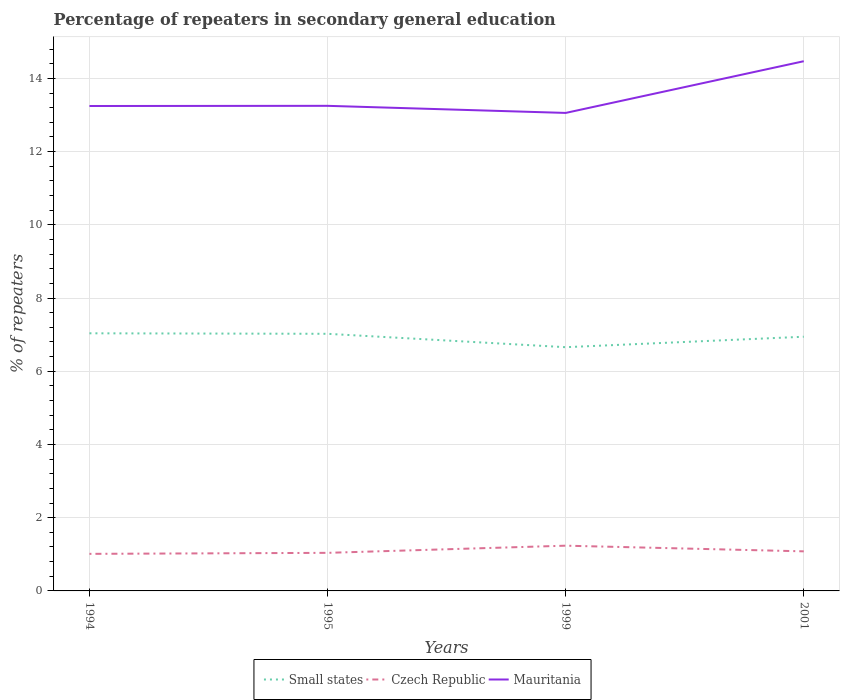Does the line corresponding to Mauritania intersect with the line corresponding to Czech Republic?
Your answer should be compact. No. Is the number of lines equal to the number of legend labels?
Provide a short and direct response. Yes. Across all years, what is the maximum percentage of repeaters in secondary general education in Czech Republic?
Provide a succinct answer. 1.01. What is the total percentage of repeaters in secondary general education in Czech Republic in the graph?
Give a very brief answer. -0.07. What is the difference between the highest and the second highest percentage of repeaters in secondary general education in Czech Republic?
Ensure brevity in your answer.  0.22. Is the percentage of repeaters in secondary general education in Mauritania strictly greater than the percentage of repeaters in secondary general education in Czech Republic over the years?
Make the answer very short. No. How many lines are there?
Offer a terse response. 3. What is the difference between two consecutive major ticks on the Y-axis?
Ensure brevity in your answer.  2. Are the values on the major ticks of Y-axis written in scientific E-notation?
Provide a succinct answer. No. Where does the legend appear in the graph?
Provide a short and direct response. Bottom center. How many legend labels are there?
Your response must be concise. 3. What is the title of the graph?
Your response must be concise. Percentage of repeaters in secondary general education. What is the label or title of the X-axis?
Provide a succinct answer. Years. What is the label or title of the Y-axis?
Offer a very short reply. % of repeaters. What is the % of repeaters of Small states in 1994?
Your answer should be compact. 7.04. What is the % of repeaters in Czech Republic in 1994?
Provide a short and direct response. 1.01. What is the % of repeaters in Mauritania in 1994?
Offer a terse response. 13.25. What is the % of repeaters of Small states in 1995?
Provide a succinct answer. 7.02. What is the % of repeaters in Czech Republic in 1995?
Your response must be concise. 1.04. What is the % of repeaters in Mauritania in 1995?
Offer a terse response. 13.25. What is the % of repeaters in Small states in 1999?
Keep it short and to the point. 6.66. What is the % of repeaters in Czech Republic in 1999?
Offer a terse response. 1.24. What is the % of repeaters of Mauritania in 1999?
Give a very brief answer. 13.06. What is the % of repeaters of Small states in 2001?
Provide a short and direct response. 6.94. What is the % of repeaters of Czech Republic in 2001?
Keep it short and to the point. 1.08. What is the % of repeaters in Mauritania in 2001?
Provide a succinct answer. 14.47. Across all years, what is the maximum % of repeaters of Small states?
Keep it short and to the point. 7.04. Across all years, what is the maximum % of repeaters in Czech Republic?
Your response must be concise. 1.24. Across all years, what is the maximum % of repeaters in Mauritania?
Provide a succinct answer. 14.47. Across all years, what is the minimum % of repeaters in Small states?
Keep it short and to the point. 6.66. Across all years, what is the minimum % of repeaters in Czech Republic?
Give a very brief answer. 1.01. Across all years, what is the minimum % of repeaters of Mauritania?
Your answer should be very brief. 13.06. What is the total % of repeaters of Small states in the graph?
Give a very brief answer. 27.66. What is the total % of repeaters of Czech Republic in the graph?
Give a very brief answer. 4.37. What is the total % of repeaters in Mauritania in the graph?
Offer a very short reply. 54.02. What is the difference between the % of repeaters of Small states in 1994 and that in 1995?
Offer a very short reply. 0.01. What is the difference between the % of repeaters of Czech Republic in 1994 and that in 1995?
Your answer should be compact. -0.03. What is the difference between the % of repeaters of Mauritania in 1994 and that in 1995?
Offer a very short reply. -0. What is the difference between the % of repeaters in Small states in 1994 and that in 1999?
Make the answer very short. 0.38. What is the difference between the % of repeaters of Czech Republic in 1994 and that in 1999?
Make the answer very short. -0.22. What is the difference between the % of repeaters of Mauritania in 1994 and that in 1999?
Ensure brevity in your answer.  0.19. What is the difference between the % of repeaters in Small states in 1994 and that in 2001?
Make the answer very short. 0.09. What is the difference between the % of repeaters in Czech Republic in 1994 and that in 2001?
Your answer should be compact. -0.07. What is the difference between the % of repeaters in Mauritania in 1994 and that in 2001?
Make the answer very short. -1.22. What is the difference between the % of repeaters of Small states in 1995 and that in 1999?
Offer a very short reply. 0.37. What is the difference between the % of repeaters in Czech Republic in 1995 and that in 1999?
Your answer should be compact. -0.2. What is the difference between the % of repeaters of Mauritania in 1995 and that in 1999?
Ensure brevity in your answer.  0.19. What is the difference between the % of repeaters of Small states in 1995 and that in 2001?
Give a very brief answer. 0.08. What is the difference between the % of repeaters in Czech Republic in 1995 and that in 2001?
Offer a very short reply. -0.04. What is the difference between the % of repeaters of Mauritania in 1995 and that in 2001?
Ensure brevity in your answer.  -1.22. What is the difference between the % of repeaters in Small states in 1999 and that in 2001?
Provide a short and direct response. -0.29. What is the difference between the % of repeaters in Czech Republic in 1999 and that in 2001?
Provide a succinct answer. 0.15. What is the difference between the % of repeaters in Mauritania in 1999 and that in 2001?
Your answer should be compact. -1.41. What is the difference between the % of repeaters of Small states in 1994 and the % of repeaters of Czech Republic in 1995?
Provide a succinct answer. 6. What is the difference between the % of repeaters in Small states in 1994 and the % of repeaters in Mauritania in 1995?
Offer a very short reply. -6.21. What is the difference between the % of repeaters of Czech Republic in 1994 and the % of repeaters of Mauritania in 1995?
Your answer should be compact. -12.24. What is the difference between the % of repeaters in Small states in 1994 and the % of repeaters in Czech Republic in 1999?
Your answer should be compact. 5.8. What is the difference between the % of repeaters in Small states in 1994 and the % of repeaters in Mauritania in 1999?
Give a very brief answer. -6.02. What is the difference between the % of repeaters in Czech Republic in 1994 and the % of repeaters in Mauritania in 1999?
Give a very brief answer. -12.04. What is the difference between the % of repeaters of Small states in 1994 and the % of repeaters of Czech Republic in 2001?
Make the answer very short. 5.96. What is the difference between the % of repeaters of Small states in 1994 and the % of repeaters of Mauritania in 2001?
Your answer should be compact. -7.43. What is the difference between the % of repeaters of Czech Republic in 1994 and the % of repeaters of Mauritania in 2001?
Provide a succinct answer. -13.46. What is the difference between the % of repeaters in Small states in 1995 and the % of repeaters in Czech Republic in 1999?
Your answer should be very brief. 5.79. What is the difference between the % of repeaters of Small states in 1995 and the % of repeaters of Mauritania in 1999?
Offer a very short reply. -6.03. What is the difference between the % of repeaters of Czech Republic in 1995 and the % of repeaters of Mauritania in 1999?
Your answer should be compact. -12.02. What is the difference between the % of repeaters in Small states in 1995 and the % of repeaters in Czech Republic in 2001?
Give a very brief answer. 5.94. What is the difference between the % of repeaters of Small states in 1995 and the % of repeaters of Mauritania in 2001?
Give a very brief answer. -7.45. What is the difference between the % of repeaters in Czech Republic in 1995 and the % of repeaters in Mauritania in 2001?
Offer a terse response. -13.43. What is the difference between the % of repeaters in Small states in 1999 and the % of repeaters in Czech Republic in 2001?
Your answer should be compact. 5.58. What is the difference between the % of repeaters in Small states in 1999 and the % of repeaters in Mauritania in 2001?
Your response must be concise. -7.81. What is the difference between the % of repeaters of Czech Republic in 1999 and the % of repeaters of Mauritania in 2001?
Give a very brief answer. -13.23. What is the average % of repeaters in Small states per year?
Offer a very short reply. 6.92. What is the average % of repeaters of Czech Republic per year?
Make the answer very short. 1.09. What is the average % of repeaters in Mauritania per year?
Make the answer very short. 13.51. In the year 1994, what is the difference between the % of repeaters of Small states and % of repeaters of Czech Republic?
Offer a very short reply. 6.02. In the year 1994, what is the difference between the % of repeaters of Small states and % of repeaters of Mauritania?
Your response must be concise. -6.21. In the year 1994, what is the difference between the % of repeaters of Czech Republic and % of repeaters of Mauritania?
Your answer should be very brief. -12.23. In the year 1995, what is the difference between the % of repeaters in Small states and % of repeaters in Czech Republic?
Your answer should be compact. 5.98. In the year 1995, what is the difference between the % of repeaters of Small states and % of repeaters of Mauritania?
Provide a short and direct response. -6.23. In the year 1995, what is the difference between the % of repeaters of Czech Republic and % of repeaters of Mauritania?
Offer a very short reply. -12.21. In the year 1999, what is the difference between the % of repeaters in Small states and % of repeaters in Czech Republic?
Your answer should be compact. 5.42. In the year 1999, what is the difference between the % of repeaters in Small states and % of repeaters in Mauritania?
Provide a short and direct response. -6.4. In the year 1999, what is the difference between the % of repeaters of Czech Republic and % of repeaters of Mauritania?
Ensure brevity in your answer.  -11.82. In the year 2001, what is the difference between the % of repeaters of Small states and % of repeaters of Czech Republic?
Make the answer very short. 5.86. In the year 2001, what is the difference between the % of repeaters of Small states and % of repeaters of Mauritania?
Your response must be concise. -7.53. In the year 2001, what is the difference between the % of repeaters in Czech Republic and % of repeaters in Mauritania?
Offer a very short reply. -13.39. What is the ratio of the % of repeaters of Small states in 1994 to that in 1995?
Ensure brevity in your answer.  1. What is the ratio of the % of repeaters in Czech Republic in 1994 to that in 1995?
Keep it short and to the point. 0.97. What is the ratio of the % of repeaters of Mauritania in 1994 to that in 1995?
Make the answer very short. 1. What is the ratio of the % of repeaters in Small states in 1994 to that in 1999?
Provide a short and direct response. 1.06. What is the ratio of the % of repeaters in Czech Republic in 1994 to that in 1999?
Offer a terse response. 0.82. What is the ratio of the % of repeaters of Mauritania in 1994 to that in 1999?
Provide a short and direct response. 1.01. What is the ratio of the % of repeaters of Small states in 1994 to that in 2001?
Offer a terse response. 1.01. What is the ratio of the % of repeaters of Czech Republic in 1994 to that in 2001?
Keep it short and to the point. 0.94. What is the ratio of the % of repeaters of Mauritania in 1994 to that in 2001?
Offer a very short reply. 0.92. What is the ratio of the % of repeaters of Small states in 1995 to that in 1999?
Your answer should be compact. 1.05. What is the ratio of the % of repeaters of Czech Republic in 1995 to that in 1999?
Offer a terse response. 0.84. What is the ratio of the % of repeaters in Mauritania in 1995 to that in 1999?
Your answer should be very brief. 1.01. What is the ratio of the % of repeaters in Small states in 1995 to that in 2001?
Make the answer very short. 1.01. What is the ratio of the % of repeaters of Czech Republic in 1995 to that in 2001?
Provide a succinct answer. 0.96. What is the ratio of the % of repeaters of Mauritania in 1995 to that in 2001?
Give a very brief answer. 0.92. What is the ratio of the % of repeaters in Small states in 1999 to that in 2001?
Your answer should be compact. 0.96. What is the ratio of the % of repeaters in Czech Republic in 1999 to that in 2001?
Ensure brevity in your answer.  1.14. What is the ratio of the % of repeaters of Mauritania in 1999 to that in 2001?
Provide a succinct answer. 0.9. What is the difference between the highest and the second highest % of repeaters in Small states?
Your response must be concise. 0.01. What is the difference between the highest and the second highest % of repeaters of Czech Republic?
Ensure brevity in your answer.  0.15. What is the difference between the highest and the second highest % of repeaters in Mauritania?
Provide a short and direct response. 1.22. What is the difference between the highest and the lowest % of repeaters in Small states?
Ensure brevity in your answer.  0.38. What is the difference between the highest and the lowest % of repeaters in Czech Republic?
Keep it short and to the point. 0.22. What is the difference between the highest and the lowest % of repeaters in Mauritania?
Give a very brief answer. 1.41. 